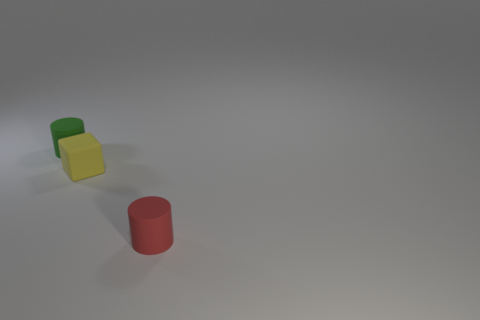How many cylinders are the same color as the rubber block?
Your answer should be very brief. 0. Does the tiny object behind the tiny yellow matte cube have the same shape as the small red object?
Your answer should be very brief. Yes. Is the number of small cylinders in front of the tiny green rubber cylinder less than the number of tiny objects behind the red rubber cylinder?
Offer a terse response. Yes. Is there a green cylinder of the same size as the red thing?
Your answer should be very brief. Yes. There is a small green thing; does it have the same shape as the rubber thing to the right of the yellow thing?
Keep it short and to the point. Yes. There is a cylinder behind the tiny red cylinder; does it have the same size as the matte thing on the right side of the yellow matte thing?
Your answer should be very brief. Yes. How many other things are the same shape as the green thing?
Give a very brief answer. 1. What material is the cylinder that is left of the rubber cylinder that is right of the cube made of?
Keep it short and to the point. Rubber. How many metal things are big objects or small green cylinders?
Offer a very short reply. 0. Is there a tiny red thing that is in front of the rubber cylinder on the right side of the small green matte thing?
Your answer should be very brief. No. 